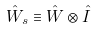<formula> <loc_0><loc_0><loc_500><loc_500>\hat { W } _ { s } \equiv \hat { W } \otimes \hat { I }</formula> 